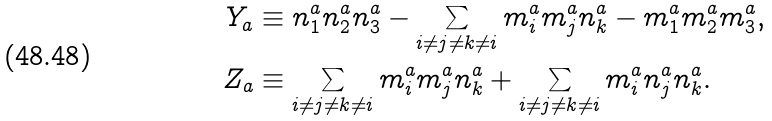<formula> <loc_0><loc_0><loc_500><loc_500>Y _ { a } & \equiv n ^ { a } _ { 1 } n ^ { a } _ { 2 } n ^ { a } _ { 3 } - \sum _ { i \neq j \neq k \neq i } m ^ { a } _ { i } m ^ { a } _ { j } n ^ { a } _ { k } - m ^ { a } _ { 1 } m ^ { a } _ { 2 } m ^ { a } _ { 3 } , \\ Z _ { a } & \equiv \sum _ { i \neq j \neq k \neq i } m ^ { a } _ { i } m ^ { a } _ { j } n ^ { a } _ { k } + \sum _ { i \neq j \neq k \neq i } m ^ { a } _ { i } n ^ { a } _ { j } n ^ { a } _ { k } .</formula> 